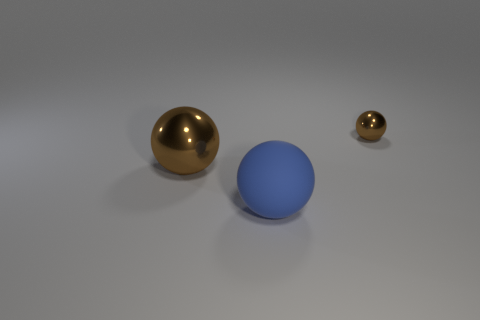How many objects are in the image, and can you describe them? There are three objects in the image: a large golden sphere, a smaller golden sphere, and a medium-sized blue sphere. All have a smooth texture and are placed on a flat surface. 